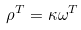Convert formula to latex. <formula><loc_0><loc_0><loc_500><loc_500>\rho ^ { T } = \kappa \omega ^ { T }</formula> 